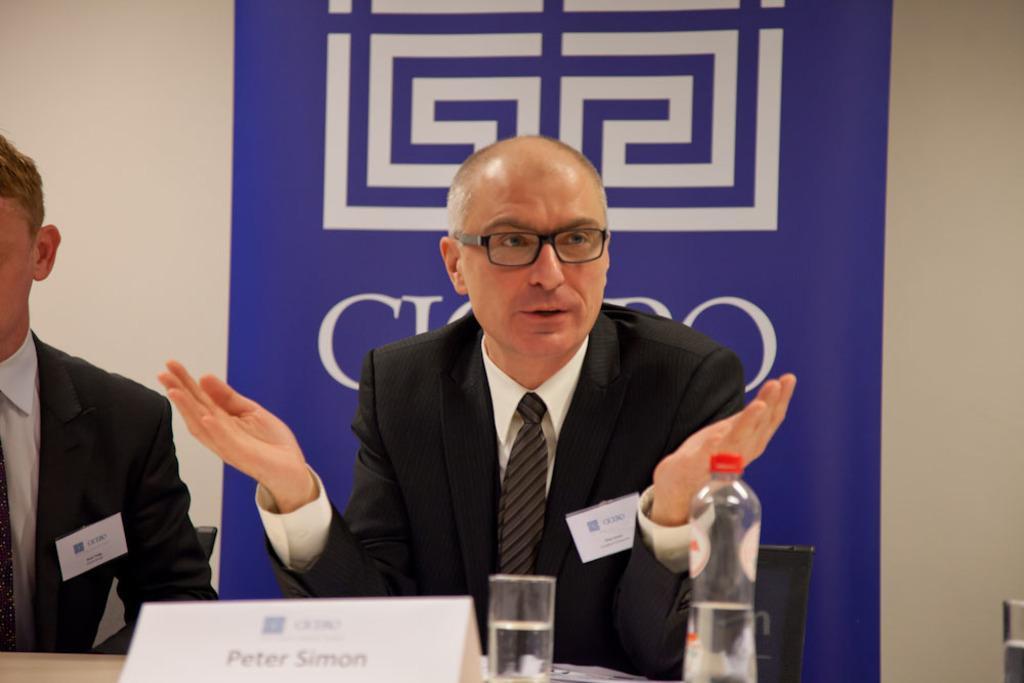Please provide a concise description of this image. In this image, we can see two people are in a suit. Here a person is talking and wearing glasses. Background there is a banner and wall. At the bottom, we can see name board, glasses with water, bottle and some objects we can see. 